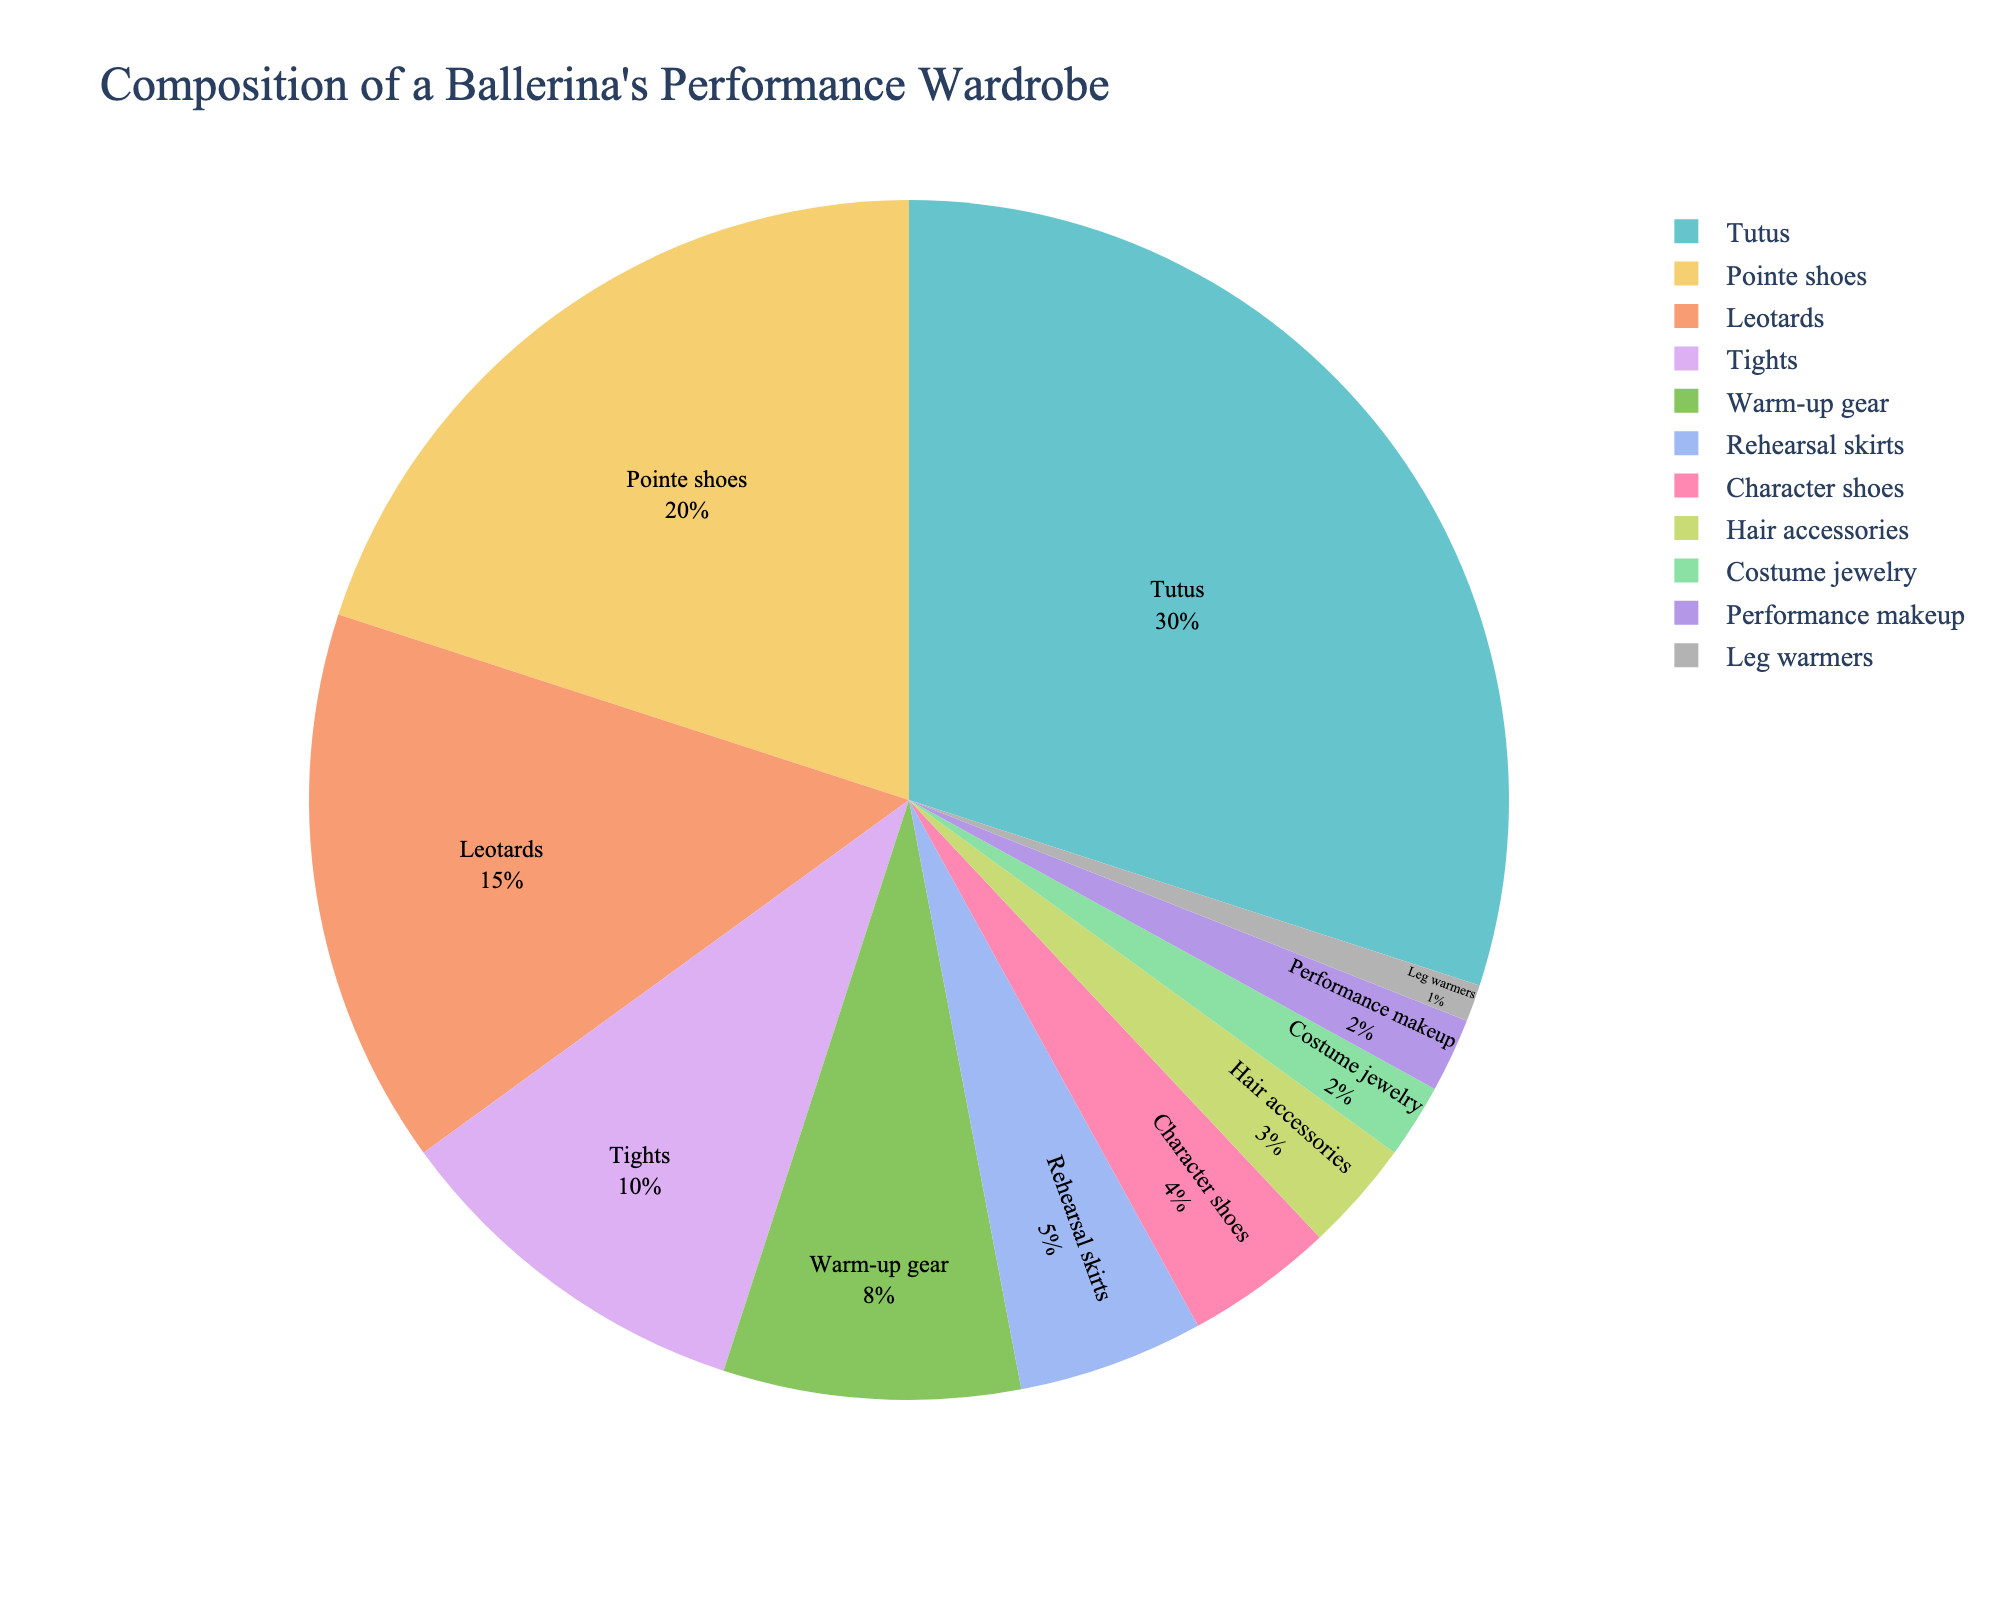What is the most significant item in the ballerina's performance wardrobe? The pie chart shows that Tutus take up the largest portion with 30% of the total wardrobe composition.
Answer: Tutus What is the combined percentage of Leotards and Tights? Leotards make up 15%, and Tights make up 10%. Adding these together gives 15 + 10 = 25%.
Answer: 25% Which has a higher percentage in the wardrobe: Pointe shoes or Warm-up gear? Pointe shoes account for 20% whereas Warm-up gear accounts for 8%. Comparing these, 20% is greater than 8%.
Answer: Pointe shoes What is the difference in percentage between Rehearsal skirts and Character shoes? Rehearsal skirts have 5%, and Character shoes have 4%. The difference is 5 - 4 = 1%.
Answer: 1% List the items that make up less than 5% of the wardrobe. The pie chart shows that Character shoes (4%), Hair accessories (3%), Costume jewelry (2%), Performance makeup (2%), and Leg warmers (1%) all make up less than 5% of the wardrobe.
Answer: Character shoes, Hair accessories, Costume jewelry, Performance makeup, Leg warmers Which item has the lowest percentage in the wardrobe? Leg warmers have the smallest percentage, accounting for only 1% of the wardrobe.
Answer: Leg warmers What is the percentage of items related to clothing (Tutus, Leotards, Tights, Warm-up gear, Rehearsal skirts) compared to non-clothing items (Pointe shoes, Character shoes, Hair accessories, Costume jewelry, Performance makeup, Leg warmers)? Sum of clothing items: Tutus (30) + Leotards (15) + Tights (10) + Warm-up gear (8) + Rehearsal skirts (5) = 68%. Sum of non-clothing items: Pointe shoes (20) + Character shoes (4) + Hair accessories (3) + Costume jewelry (2) + Performance makeup (2) + Leg warmers (1) = 32%.
Answer: Clothing: 68%, Non-clothing: 32% What two items together make up exactly 50% of the wardrobe? Pointe shoes (20%) and Leotards (15%) together make 35%. Pointe shoes (20%) and Tights (10%) together make 30%. Tutus (30%) and Pointe shoes (20%) together make 50%. None of the other combinations reach exactly 50%.
Answer: Tutus and Pointe shoes How much more percentage do Warm-up gear and Rehearsal skirts combined have than Performance makeup and Leg warmers combined? Warm-up gear: 8%, Rehearsal skirts: 5%, combined: 8 + 5 = 13%. Performance makeup: 2%, Leg warmers: 1%, combined: 2 + 1 = 3%. Difference: 13 - 3 = 10%.
Answer: 10% 